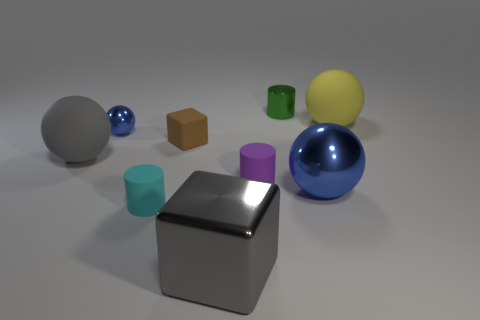Is the material of the small brown object the same as the gray object that is left of the brown rubber thing?
Your response must be concise. Yes. Are there fewer tiny brown objects than purple spheres?
Offer a very short reply. No. Is there anything else that has the same color as the big shiny sphere?
Offer a terse response. Yes. There is a green object that is made of the same material as the big blue object; what shape is it?
Ensure brevity in your answer.  Cylinder. What number of green shiny cylinders are behind the tiny thing that is in front of the blue metal ball on the right side of the metal cylinder?
Your response must be concise. 1. There is a tiny object that is both right of the small brown thing and in front of the yellow ball; what is its shape?
Your response must be concise. Cylinder. Are there fewer cyan rubber things that are behind the large yellow rubber thing than green objects?
Your answer should be compact. Yes. What number of tiny objects are either red balls or green metallic things?
Offer a terse response. 1. What size is the green cylinder?
Ensure brevity in your answer.  Small. Is there any other thing that has the same material as the small purple thing?
Offer a very short reply. Yes. 